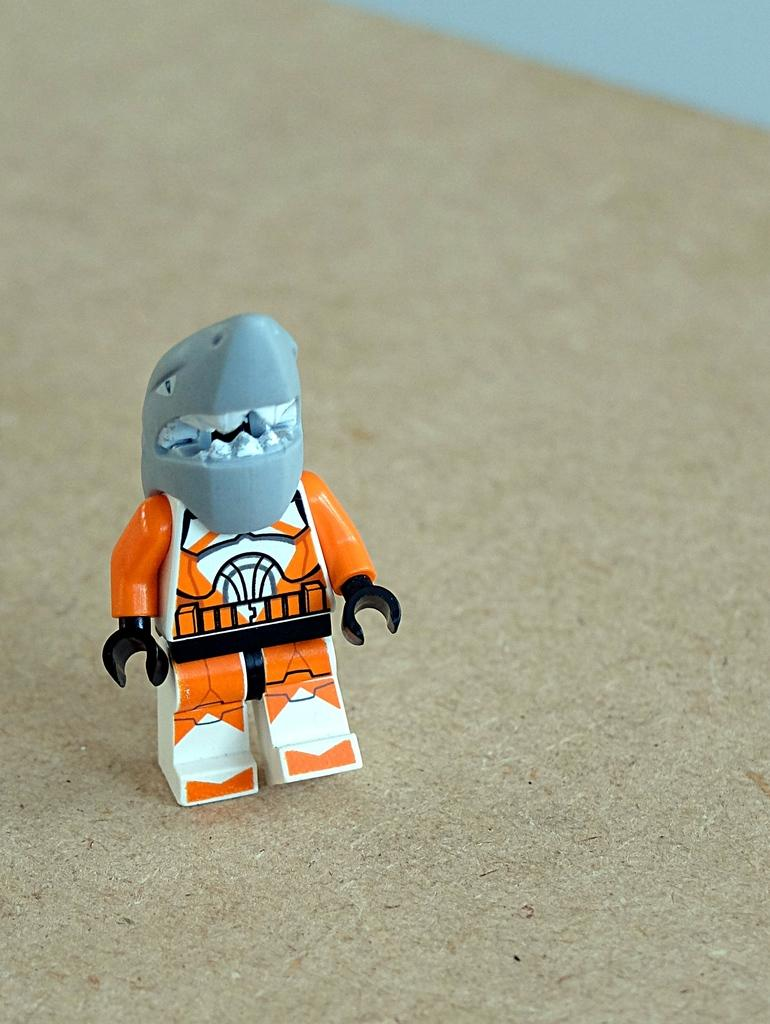What object can be seen in the image? There is a toy in the image. Where is the toy located? The toy is on a platform. What type of wax can be seen on the moon in the image? There is no moon or wax present in the image; it only features a toy on a platform. 